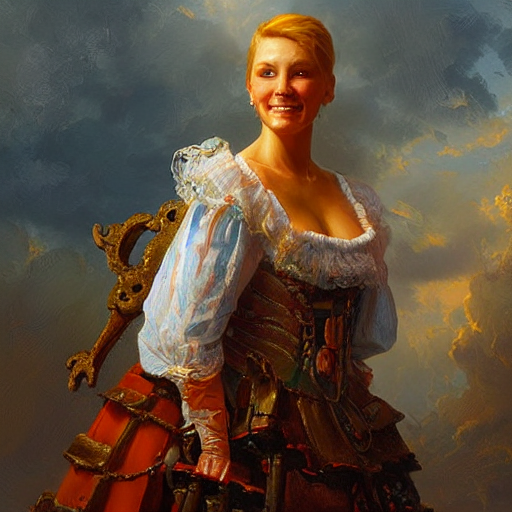What might be the significance of the object that the person is leaning on? The object seems to be a decorative, antique chair with an intricate design, which could signify a connection to nobility or a high social standing within the historical context suggested by her attire. 